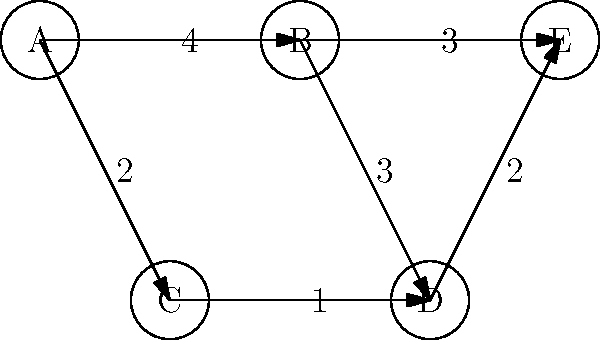In a healthcare analytics platform, you're analyzing a patient referral network represented by the graph above. Each node represents a medical facility, and each edge represents a referral path with its associated cost (in hours). What is the shortest path from facility A to facility E, and what is its total cost? To find the shortest path from A to E, we'll use Dijkstra's algorithm:

1. Initialize:
   - Distance to A: 0
   - Distance to all other nodes: $\infty$
   - Set of unvisited nodes: {A, B, C, D, E}

2. From A:
   - Update B: min($\infty$, 0 + 4) = 4
   - Update C: min($\infty$, 0 + 2) = 2
   - Mark A as visited

3. From C (closest unvisited node):
   - Update D: min($\infty$, 2 + 1) = 3
   - Mark C as visited

4. From D:
   - Update E: min($\infty$, 3 + 2) = 5
   - Mark D as visited

5. From B:
   - Cannot improve any paths
   - Mark B as visited

6. E is the only unvisited node left, so we're done.

The shortest path is A -> C -> D -> E with a total cost of 5 hours.
Answer: A -> C -> D -> E, 5 hours 